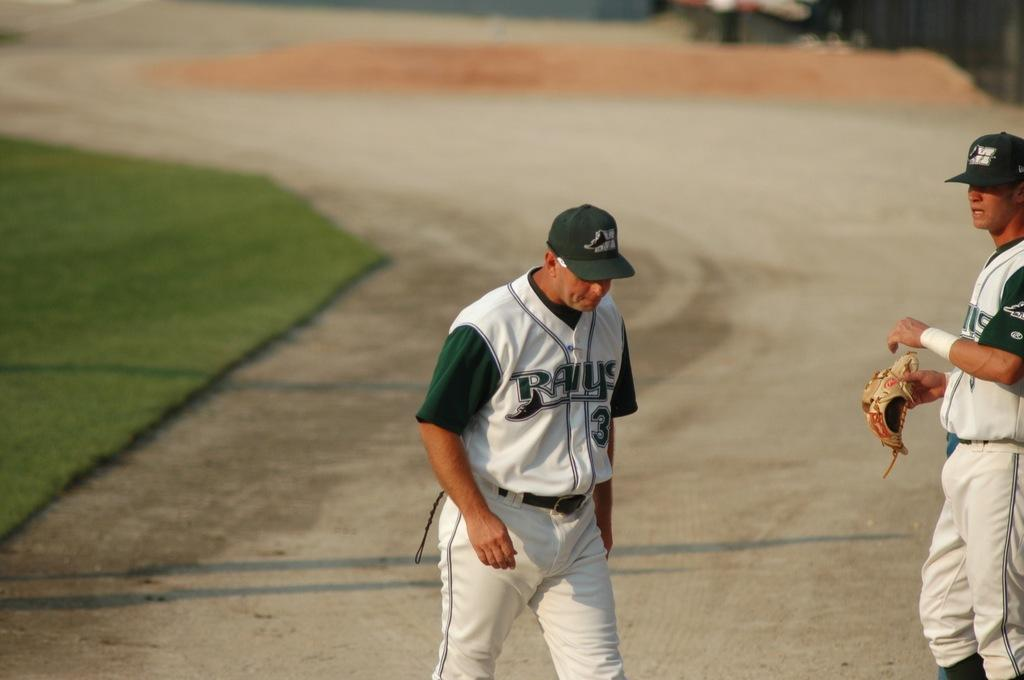<image>
Write a terse but informative summary of the picture. A baseball player wearing a Rays jersey and a green cap. 